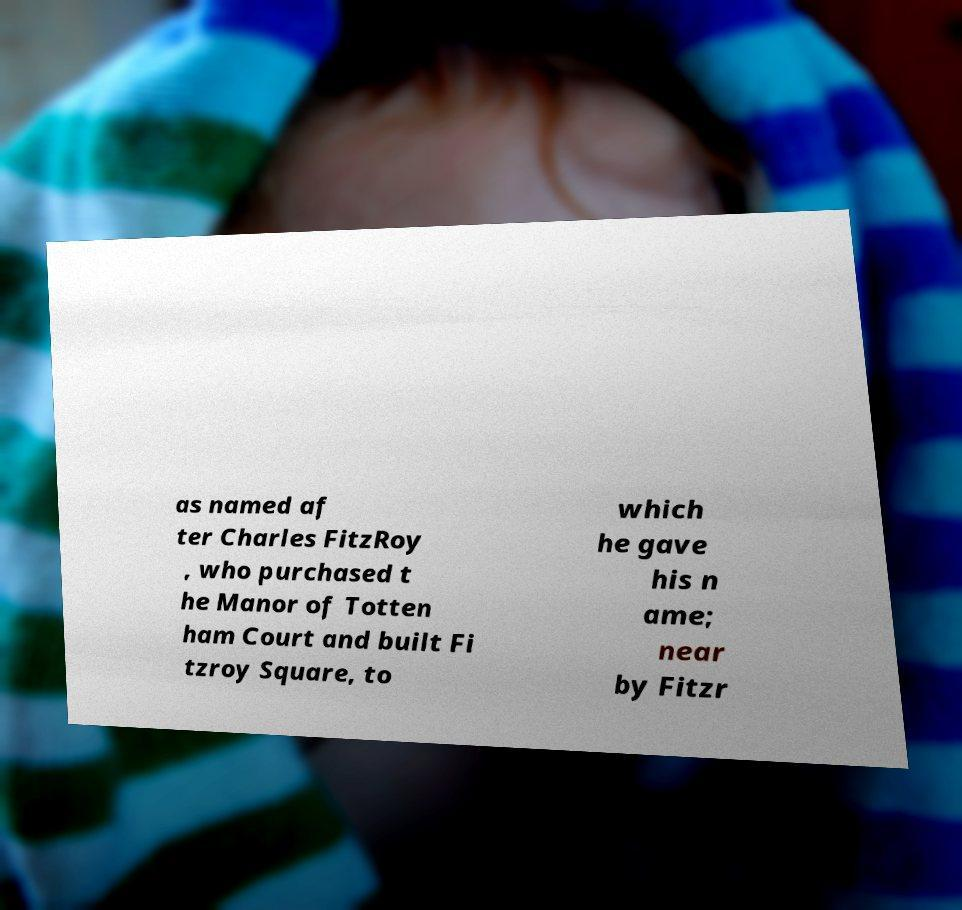There's text embedded in this image that I need extracted. Can you transcribe it verbatim? as named af ter Charles FitzRoy , who purchased t he Manor of Totten ham Court and built Fi tzroy Square, to which he gave his n ame; near by Fitzr 